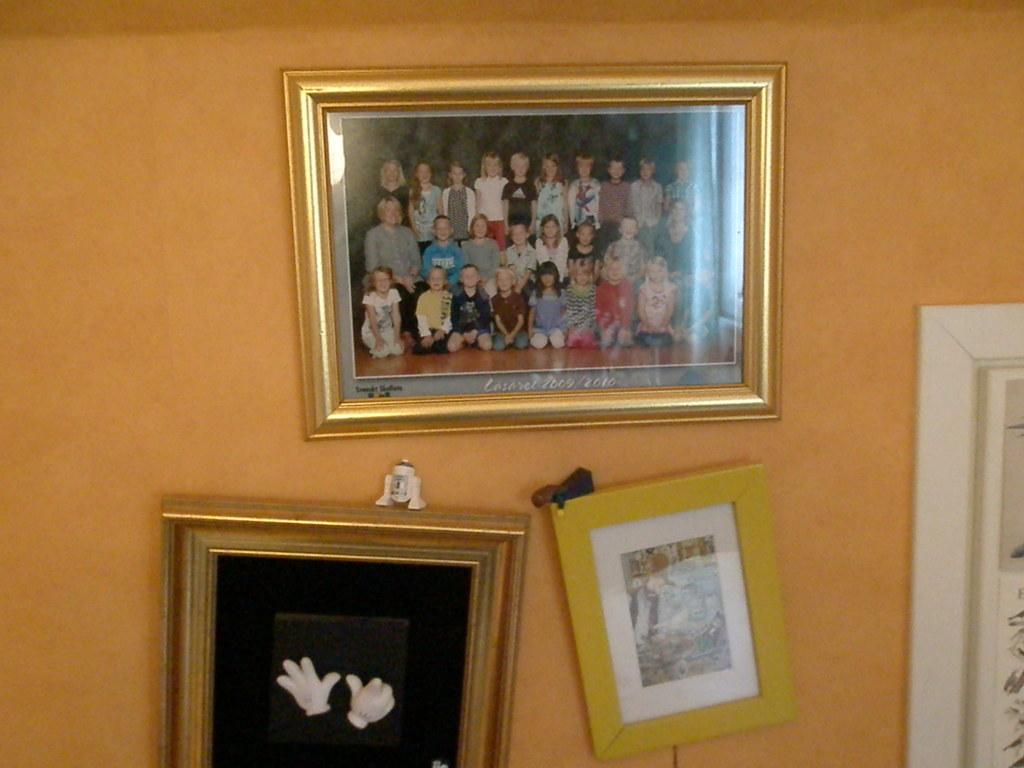<image>
Summarize the visual content of the image. a class photo that was taken in 2009 